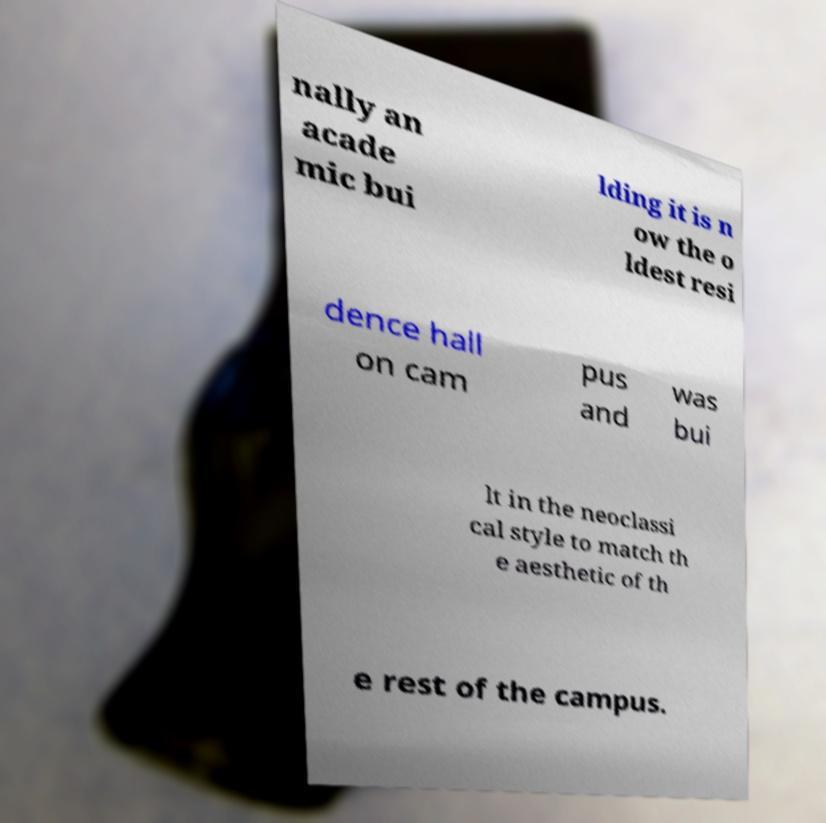Could you assist in decoding the text presented in this image and type it out clearly? nally an acade mic bui lding it is n ow the o ldest resi dence hall on cam pus and was bui lt in the neoclassi cal style to match th e aesthetic of th e rest of the campus. 